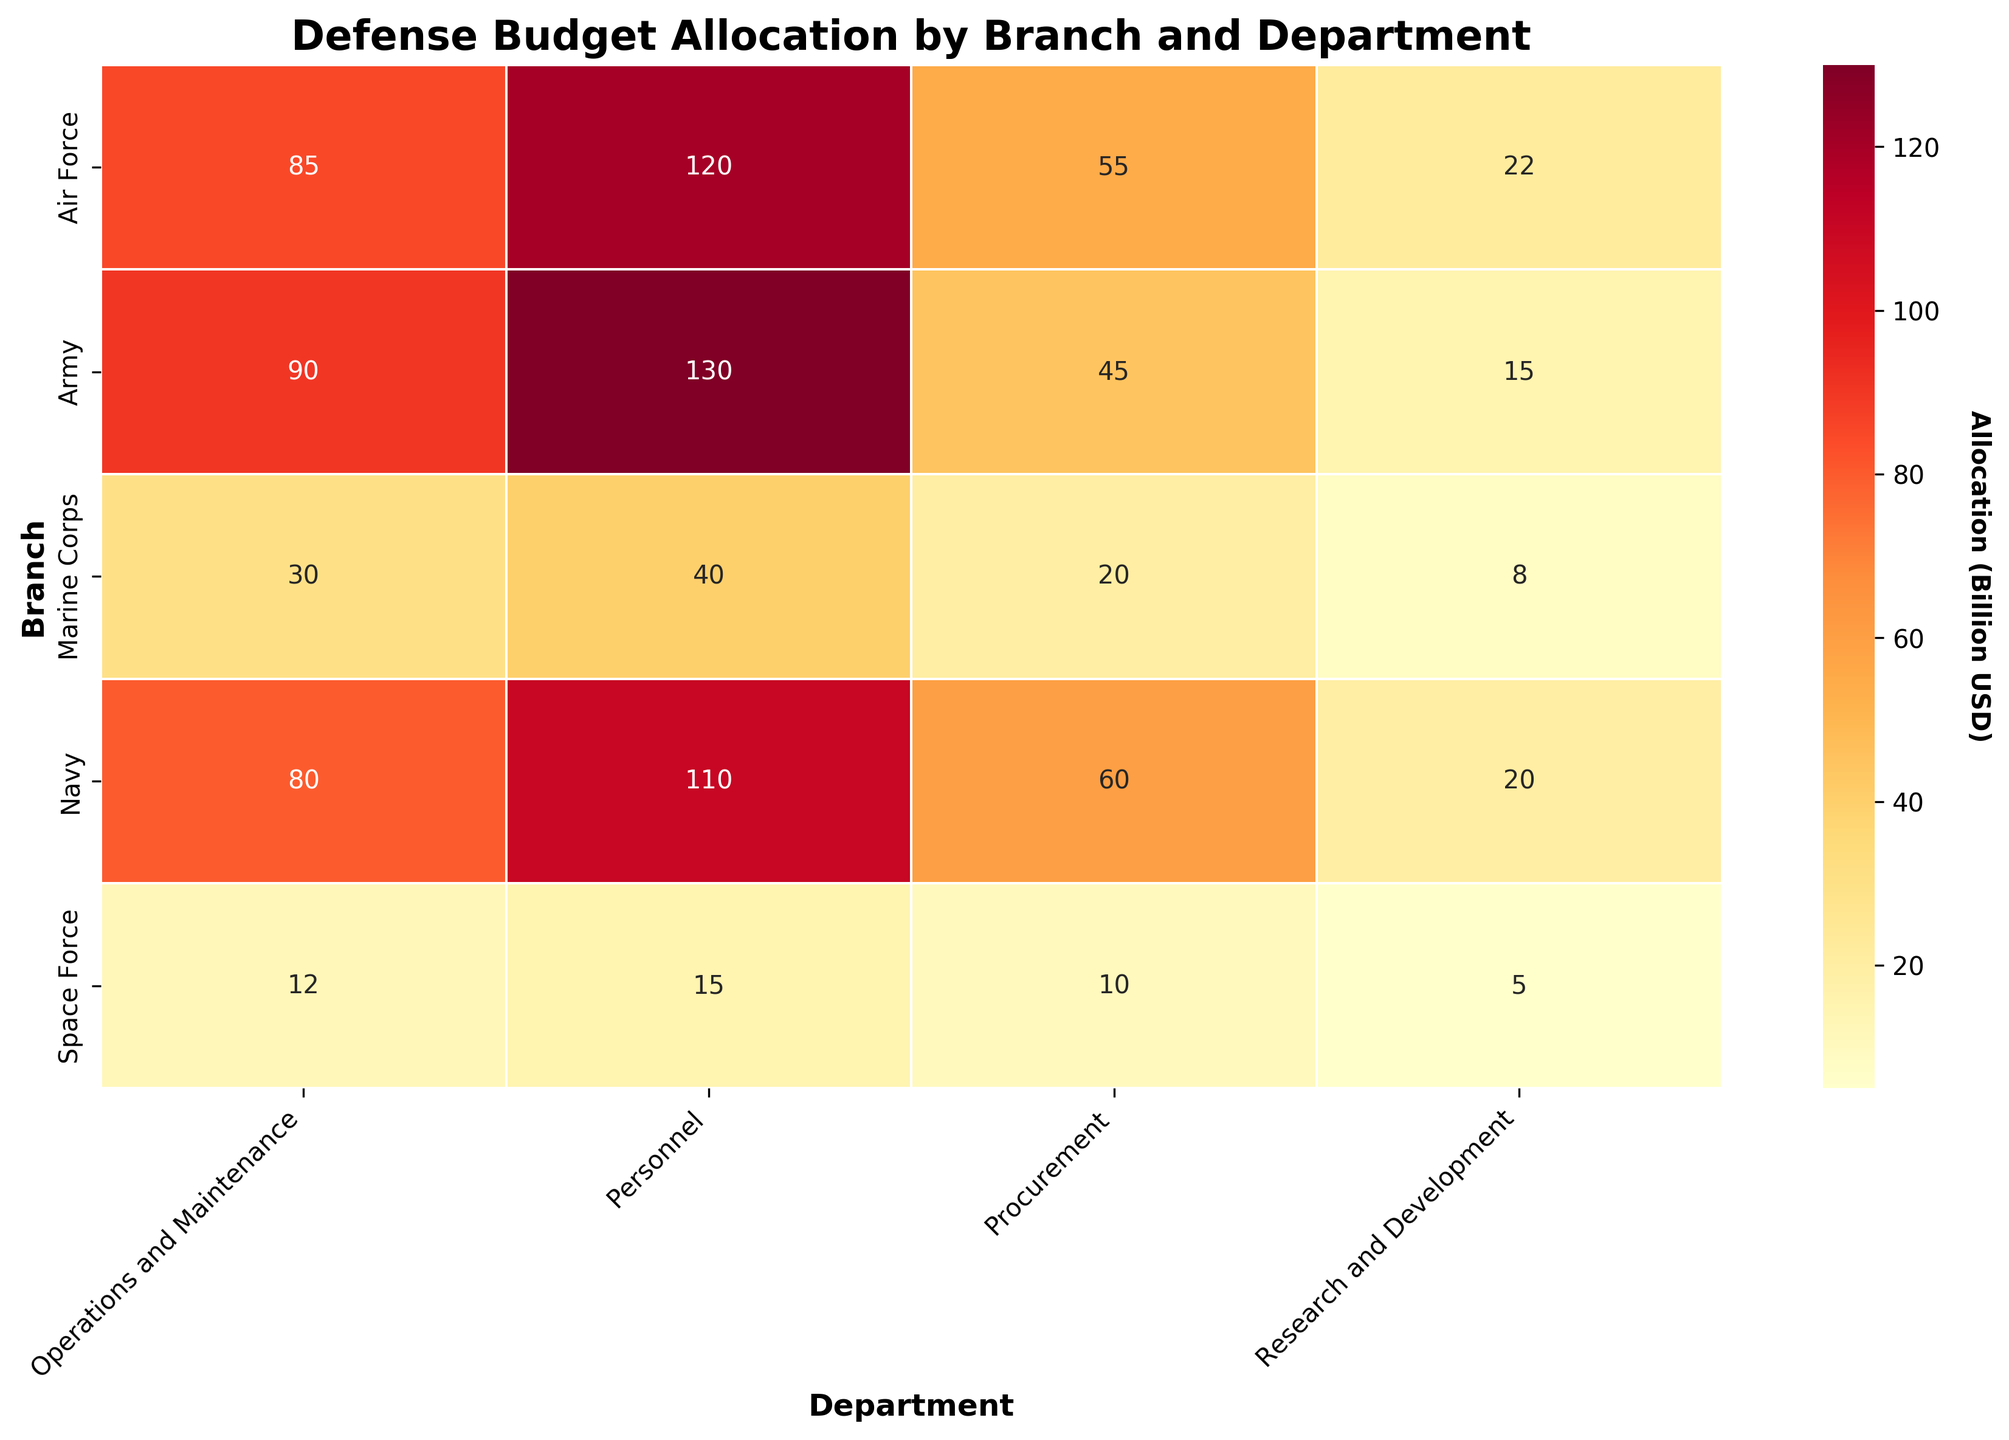what is the title of the heatmap? The title of the heatmap is clearly displayed at the top center of the figure. By looking at the top, you can read the title.
Answer: Defense Budget Allocation by Branch and Department Which department receives the highest allocation in the Army branch? By examining the values in the Army row, we can see that the Personnel department has the highest allocation. The number under Personnel for the Army is the largest.
Answer: Personnel What is the total allocation for the Navy branch across all departments? To get the total allocation for the Navy, sum the amounts from all four departments: 110 + 80 + 60 + 20. This calculation gives us the total.
Answer: 270 Which branch allocates more to Operations and Maintenance, the Air Force or the Marine Corps? Looking at the Operations and Maintenance column, check the figures for both the Air Force and Marine Corps. Compare the two numbers, 85 for the Air Force and 30 for the Marine Corps, and see that 85 is greater than 30.
Answer: Air Force How much more is allocated to Procurement than to Research and Development in the Space Force? For the Space Force, subtract the allocation for Research and Development from the allocation for Procurement: 10 - 5.
Answer: 5 Which department has the least allocation across all branches? By scanning all the values in each department column, we notice that Research and Development for the Space Force has the smallest value, which is 5.
Answer: Research and Development for Space Force How does the allocation for Personnel in the Air Force compare to the Navy? Look at the values for the Personnel department in both the Air Force and Navy rows. The numbers are 120 for the Air Force and 110 for the Navy, so 120 is greater than 110.
Answer: Air Force What is the average allocation for the Army across all departments? Find the average by summing the allocations for all departments in the Army and then dividing by the number of departments: (130 + 90 + 45 + 15) / 4 = 70.
Answer: 70 Which branch has the highest total Allocation for Research and Development? By adding the Research and Development values for each branch and comparing them, we see that the Air Force total (22) is the highest.
Answer: Air Force Does the Marine Corps allocate more to Procurement or to Operations and Maintenance? Compare the values in Procurement and Operations and Maintenance for the Marine Corps: 20 for Procurement and 30 for Operations and Maintenance. Since 30 is greater than 20, it allocates more to Operations and Maintenance.
Answer: Operations and Maintenance 